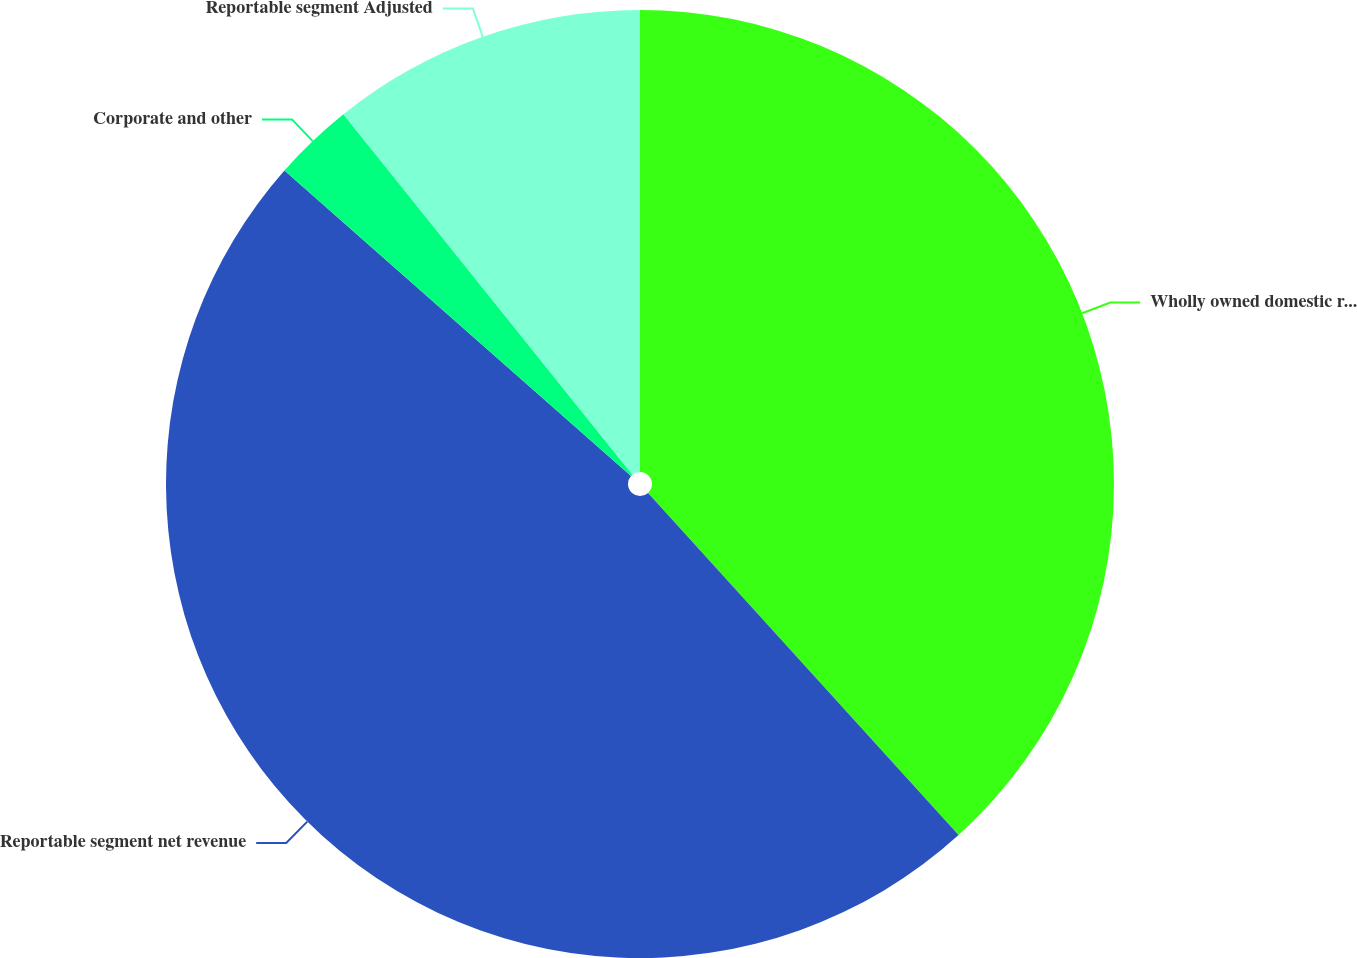Convert chart to OTSL. <chart><loc_0><loc_0><loc_500><loc_500><pie_chart><fcel>Wholly owned domestic resorts<fcel>Reportable segment net revenue<fcel>Corporate and other<fcel>Reportable segment Adjusted<nl><fcel>38.27%<fcel>48.23%<fcel>2.74%<fcel>10.76%<nl></chart> 